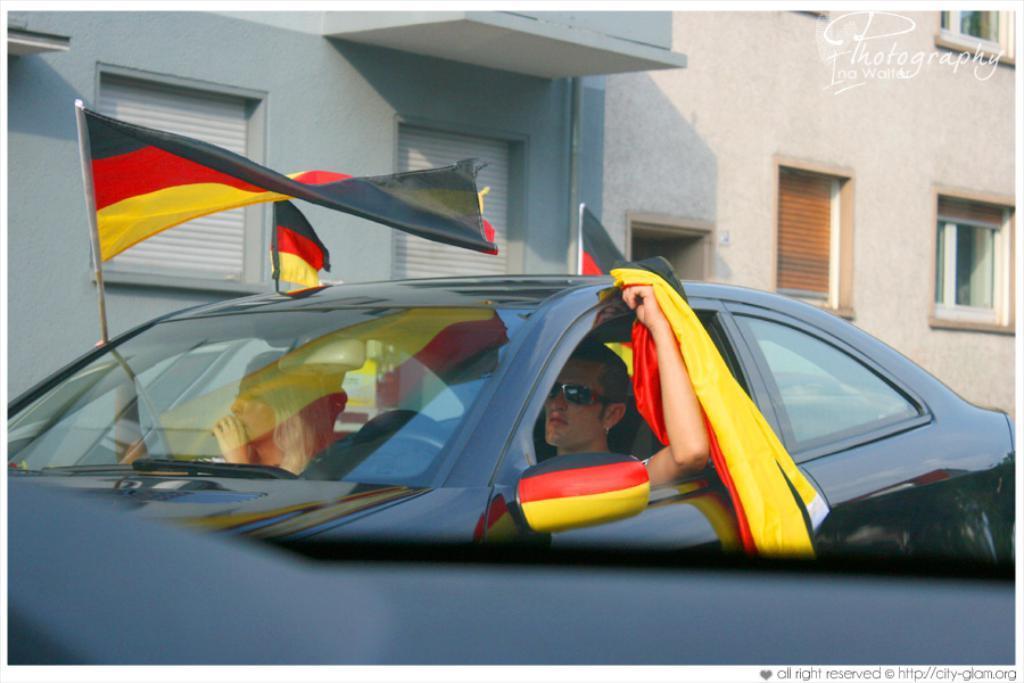Please provide a concise description of this image. In this image we can see a man and a woman sitting inside a car holding the flags. On the backside we can see a building with windows. 